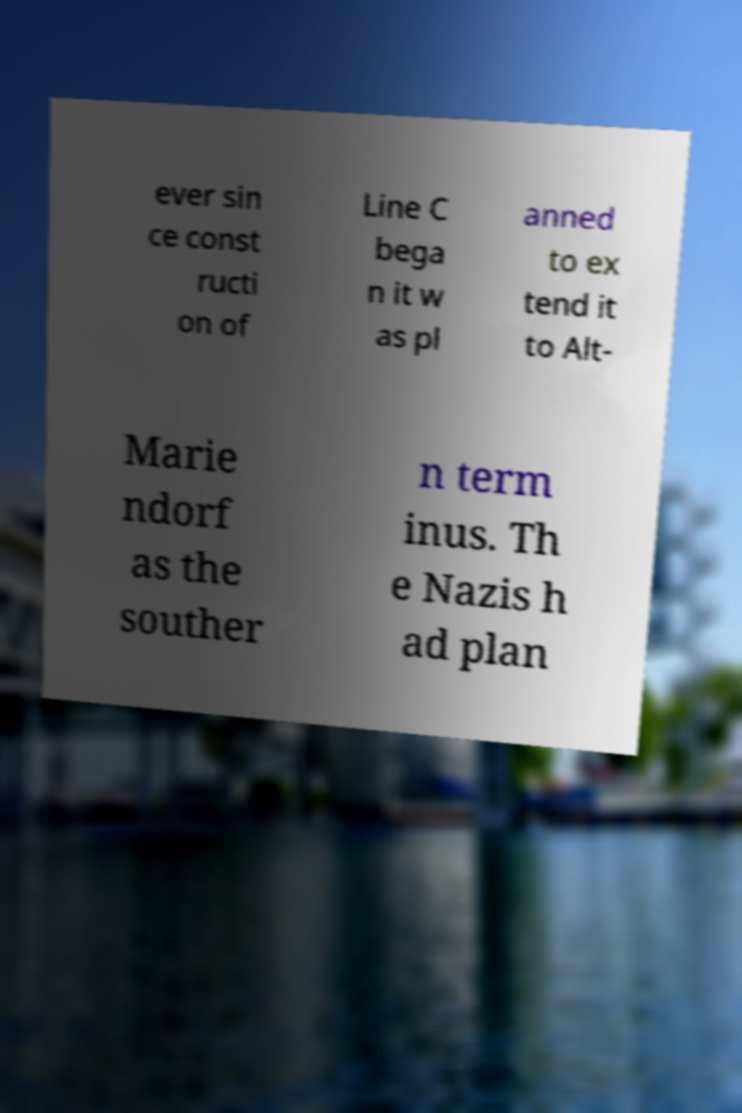Could you extract and type out the text from this image? ever sin ce const ructi on of Line C bega n it w as pl anned to ex tend it to Alt- Marie ndorf as the souther n term inus. Th e Nazis h ad plan 